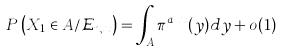<formula> <loc_0><loc_0><loc_500><loc_500>P \left ( X _ { 1 } \in A / \mathcal { E } _ { n , x } \right ) = \int _ { A } \pi ^ { a _ { n } x } ( y ) d y + o ( 1 )</formula> 